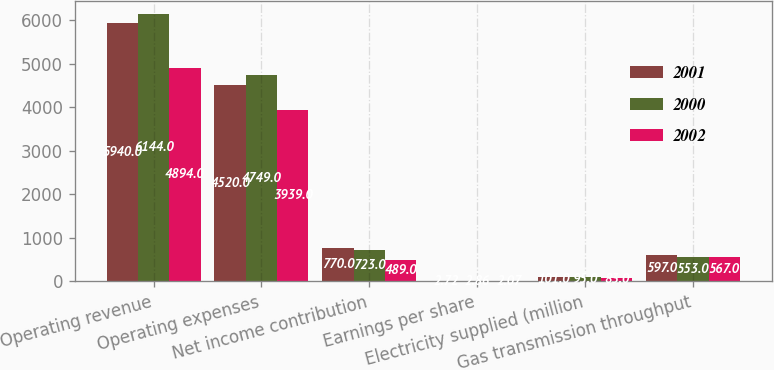<chart> <loc_0><loc_0><loc_500><loc_500><stacked_bar_chart><ecel><fcel>Operating revenue<fcel>Operating expenses<fcel>Net income contribution<fcel>Earnings per share<fcel>Electricity supplied (million<fcel>Gas transmission throughput<nl><fcel>2001<fcel>5940<fcel>4520<fcel>770<fcel>2.72<fcel>101<fcel>597<nl><fcel>2000<fcel>6144<fcel>4749<fcel>723<fcel>2.86<fcel>95<fcel>553<nl><fcel>2002<fcel>4894<fcel>3939<fcel>489<fcel>2.07<fcel>83<fcel>567<nl></chart> 